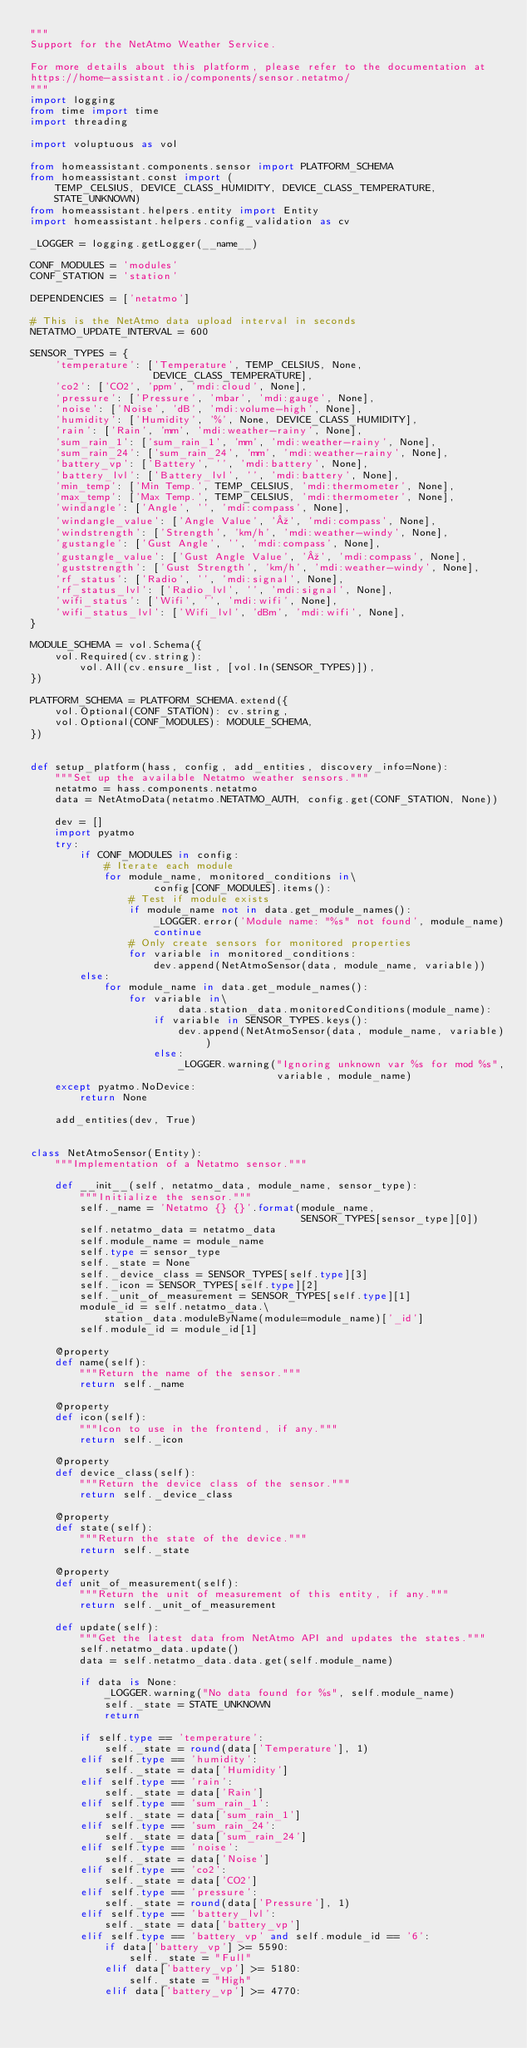<code> <loc_0><loc_0><loc_500><loc_500><_Python_>"""
Support for the NetAtmo Weather Service.

For more details about this platform, please refer to the documentation at
https://home-assistant.io/components/sensor.netatmo/
"""
import logging
from time import time
import threading

import voluptuous as vol

from homeassistant.components.sensor import PLATFORM_SCHEMA
from homeassistant.const import (
    TEMP_CELSIUS, DEVICE_CLASS_HUMIDITY, DEVICE_CLASS_TEMPERATURE,
    STATE_UNKNOWN)
from homeassistant.helpers.entity import Entity
import homeassistant.helpers.config_validation as cv

_LOGGER = logging.getLogger(__name__)

CONF_MODULES = 'modules'
CONF_STATION = 'station'

DEPENDENCIES = ['netatmo']

# This is the NetAtmo data upload interval in seconds
NETATMO_UPDATE_INTERVAL = 600

SENSOR_TYPES = {
    'temperature': ['Temperature', TEMP_CELSIUS, None,
                    DEVICE_CLASS_TEMPERATURE],
    'co2': ['CO2', 'ppm', 'mdi:cloud', None],
    'pressure': ['Pressure', 'mbar', 'mdi:gauge', None],
    'noise': ['Noise', 'dB', 'mdi:volume-high', None],
    'humidity': ['Humidity', '%', None, DEVICE_CLASS_HUMIDITY],
    'rain': ['Rain', 'mm', 'mdi:weather-rainy', None],
    'sum_rain_1': ['sum_rain_1', 'mm', 'mdi:weather-rainy', None],
    'sum_rain_24': ['sum_rain_24', 'mm', 'mdi:weather-rainy', None],
    'battery_vp': ['Battery', '', 'mdi:battery', None],
    'battery_lvl': ['Battery_lvl', '', 'mdi:battery', None],
    'min_temp': ['Min Temp.', TEMP_CELSIUS, 'mdi:thermometer', None],
    'max_temp': ['Max Temp.', TEMP_CELSIUS, 'mdi:thermometer', None],
    'windangle': ['Angle', '', 'mdi:compass', None],
    'windangle_value': ['Angle Value', 'º', 'mdi:compass', None],
    'windstrength': ['Strength', 'km/h', 'mdi:weather-windy', None],
    'gustangle': ['Gust Angle', '', 'mdi:compass', None],
    'gustangle_value': ['Gust Angle Value', 'º', 'mdi:compass', None],
    'guststrength': ['Gust Strength', 'km/h', 'mdi:weather-windy', None],
    'rf_status': ['Radio', '', 'mdi:signal', None],
    'rf_status_lvl': ['Radio_lvl', '', 'mdi:signal', None],
    'wifi_status': ['Wifi', '', 'mdi:wifi', None],
    'wifi_status_lvl': ['Wifi_lvl', 'dBm', 'mdi:wifi', None],
}

MODULE_SCHEMA = vol.Schema({
    vol.Required(cv.string):
        vol.All(cv.ensure_list, [vol.In(SENSOR_TYPES)]),
})

PLATFORM_SCHEMA = PLATFORM_SCHEMA.extend({
    vol.Optional(CONF_STATION): cv.string,
    vol.Optional(CONF_MODULES): MODULE_SCHEMA,
})


def setup_platform(hass, config, add_entities, discovery_info=None):
    """Set up the available Netatmo weather sensors."""
    netatmo = hass.components.netatmo
    data = NetAtmoData(netatmo.NETATMO_AUTH, config.get(CONF_STATION, None))

    dev = []
    import pyatmo
    try:
        if CONF_MODULES in config:
            # Iterate each module
            for module_name, monitored_conditions in\
                    config[CONF_MODULES].items():
                # Test if module exists
                if module_name not in data.get_module_names():
                    _LOGGER.error('Module name: "%s" not found', module_name)
                    continue
                # Only create sensors for monitored properties
                for variable in monitored_conditions:
                    dev.append(NetAtmoSensor(data, module_name, variable))
        else:
            for module_name in data.get_module_names():
                for variable in\
                        data.station_data.monitoredConditions(module_name):
                    if variable in SENSOR_TYPES.keys():
                        dev.append(NetAtmoSensor(data, module_name, variable))
                    else:
                        _LOGGER.warning("Ignoring unknown var %s for mod %s",
                                        variable, module_name)
    except pyatmo.NoDevice:
        return None

    add_entities(dev, True)


class NetAtmoSensor(Entity):
    """Implementation of a Netatmo sensor."""

    def __init__(self, netatmo_data, module_name, sensor_type):
        """Initialize the sensor."""
        self._name = 'Netatmo {} {}'.format(module_name,
                                            SENSOR_TYPES[sensor_type][0])
        self.netatmo_data = netatmo_data
        self.module_name = module_name
        self.type = sensor_type
        self._state = None
        self._device_class = SENSOR_TYPES[self.type][3]
        self._icon = SENSOR_TYPES[self.type][2]
        self._unit_of_measurement = SENSOR_TYPES[self.type][1]
        module_id = self.netatmo_data.\
            station_data.moduleByName(module=module_name)['_id']
        self.module_id = module_id[1]

    @property
    def name(self):
        """Return the name of the sensor."""
        return self._name

    @property
    def icon(self):
        """Icon to use in the frontend, if any."""
        return self._icon

    @property
    def device_class(self):
        """Return the device class of the sensor."""
        return self._device_class

    @property
    def state(self):
        """Return the state of the device."""
        return self._state

    @property
    def unit_of_measurement(self):
        """Return the unit of measurement of this entity, if any."""
        return self._unit_of_measurement

    def update(self):
        """Get the latest data from NetAtmo API and updates the states."""
        self.netatmo_data.update()
        data = self.netatmo_data.data.get(self.module_name)

        if data is None:
            _LOGGER.warning("No data found for %s", self.module_name)
            self._state = STATE_UNKNOWN
            return

        if self.type == 'temperature':
            self._state = round(data['Temperature'], 1)
        elif self.type == 'humidity':
            self._state = data['Humidity']
        elif self.type == 'rain':
            self._state = data['Rain']
        elif self.type == 'sum_rain_1':
            self._state = data['sum_rain_1']
        elif self.type == 'sum_rain_24':
            self._state = data['sum_rain_24']
        elif self.type == 'noise':
            self._state = data['Noise']
        elif self.type == 'co2':
            self._state = data['CO2']
        elif self.type == 'pressure':
            self._state = round(data['Pressure'], 1)
        elif self.type == 'battery_lvl':
            self._state = data['battery_vp']
        elif self.type == 'battery_vp' and self.module_id == '6':
            if data['battery_vp'] >= 5590:
                self._state = "Full"
            elif data['battery_vp'] >= 5180:
                self._state = "High"
            elif data['battery_vp'] >= 4770:</code> 